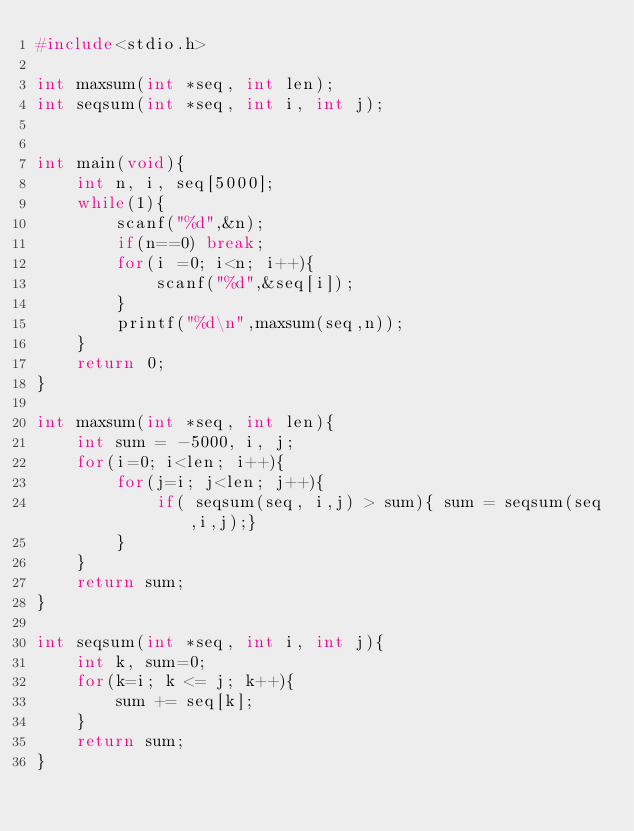<code> <loc_0><loc_0><loc_500><loc_500><_C_>#include<stdio.h>

int maxsum(int *seq, int len);
int seqsum(int *seq, int i, int j);


int main(void){
	int n, i, seq[5000];
	while(1){
		scanf("%d",&n);
		if(n==0) break;
		for(i =0; i<n; i++){
			scanf("%d",&seq[i]);
		}
		printf("%d\n",maxsum(seq,n));
	}
	return 0;
}

int maxsum(int *seq, int len){
	int sum = -5000, i, j;
	for(i=0; i<len; i++){
		for(j=i; j<len; j++){
			if( seqsum(seq, i,j) > sum){ sum = seqsum(seq,i,j);}
		}
	}
	return sum;
}

int seqsum(int *seq, int i, int j){
	int k, sum=0;
	for(k=i; k <= j; k++){
		sum += seq[k];
	}
	return sum;
}</code> 